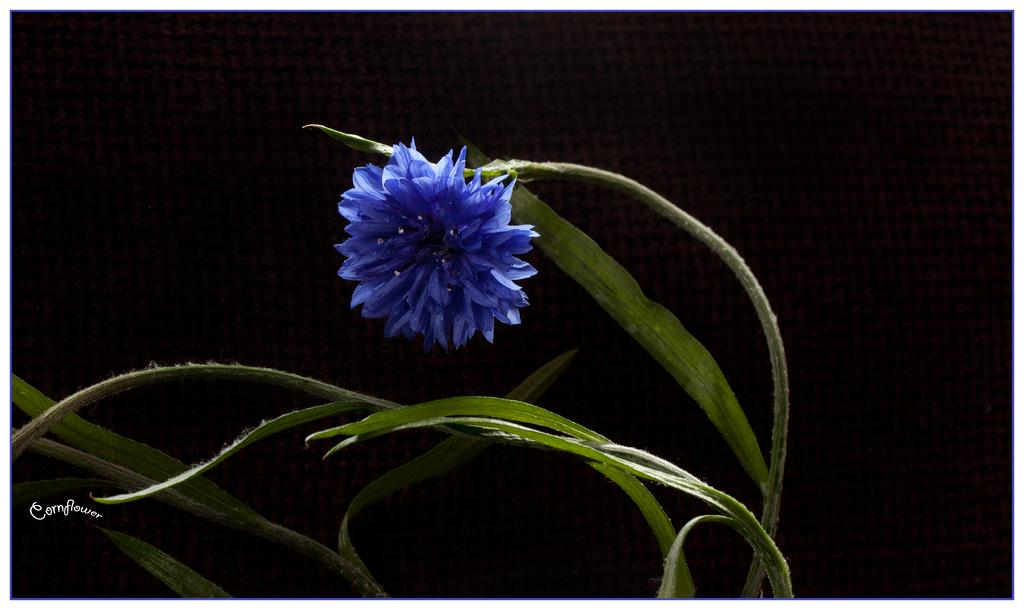What is located in the foreground of the image? There is a plant and a flower in the foreground of the image. What can be seen on the left side of the image? There is some text on the left side of the image. What is the color of the background in the image? The background of the image is black. Can you tell me how many tigers are visible in the image? There are no tigers present in the image. What type of error is being corrected in the image? There is no indication of an error being corrected in the image. 